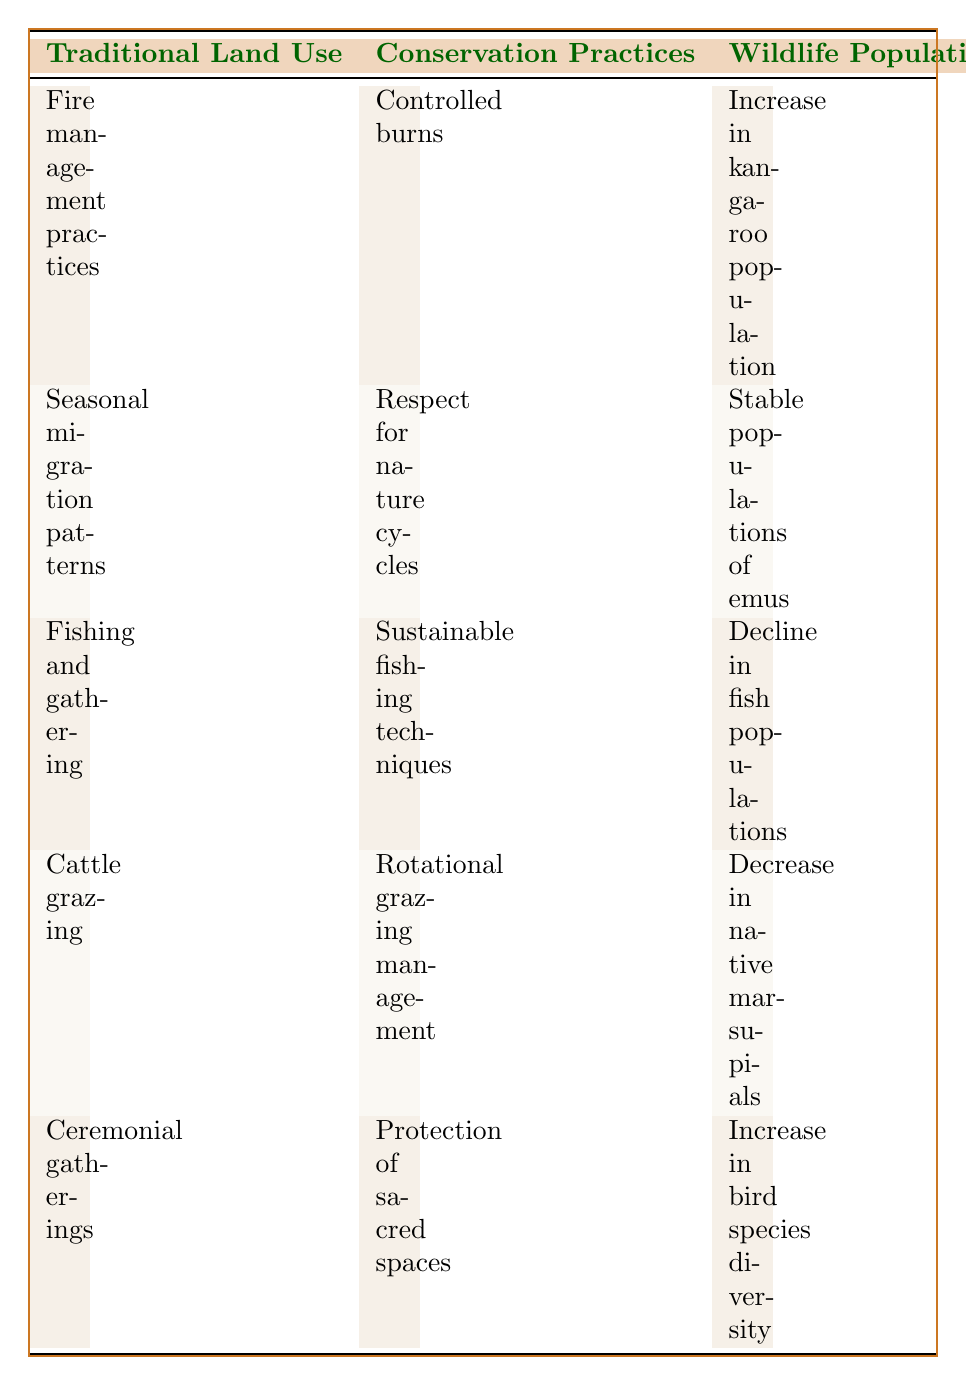What conservation practice is associated with the increase in kangaroo population? The table shows that the conservation practice associated with the increase in kangaroo population is "Controlled burns." This is found in the row for "Fire management practices."
Answer: Controlled burns Which traditional land use shows a decrease in native marsupials? According to the table, the traditional land use that shows a decrease in native marsupials is "Cattle grazing." This can be found in the respective row for this land use.
Answer: Cattle grazing Is there an increase in bird species diversity associated with ceremonial gatherings? Yes, the table indicates that there is an increase in bird species diversity associated with "Ceremonial gatherings." This is confirmed in the row specifying wildlife population trends for that land use.
Answer: Yes What is the wildlife population trend for fishing and gathering practices? The wildlife population trend for "Fishing and gathering" practices, as stated in the table, is a "Decline in fish populations." This can be identified in the corresponding row.
Answer: Decline in fish populations How many instances show an increase in wildlife population trends? The table lists three instances showing an increase in wildlife population trends: one for "Fire management practices," one for "Ceremonial gatherings," and one corresponding to a "Stable populations of emus." Therefore, when counting those rows, there are three instances of increase.
Answer: 3 If we consider only sustainable foraging practices, which ones are linked to increasing wildlife populations? The sustainable foraging practices linked to increasing wildlife populations are found in two rows. The first is "Harvesting bush tucker," linked to an increase in kangaroo population under "Fire management practices." The second is "Promoting garden areas," linked to the increase in bird species diversity under "Ceremonial gatherings."
Answer: Harvesting bush tucker and Promoting garden areas Does protecting local waterholes correspond to a positive wildlife population trend? Yes, the activity of "Protecting local waterholes" corresponds with a positive wildlife population trend, as mentioned in the row for "Fire management practices," which indicates an increase in the kangaroo population.
Answer: Yes What conservation practice relates to the collection of native fruits? The conservation practice that relates to the collection of native fruits is "Respect for nature cycles." This is mentioned in the row corresponding to "Seasonal migration patterns."
Answer: Respect for nature cycles In how many instances does rotational grazing management appear? The table shows "Rotational grazing management" appears only once, associated with "Cattle grazing." It can be identified in the respective row for that traditional land use.
Answer: 1 